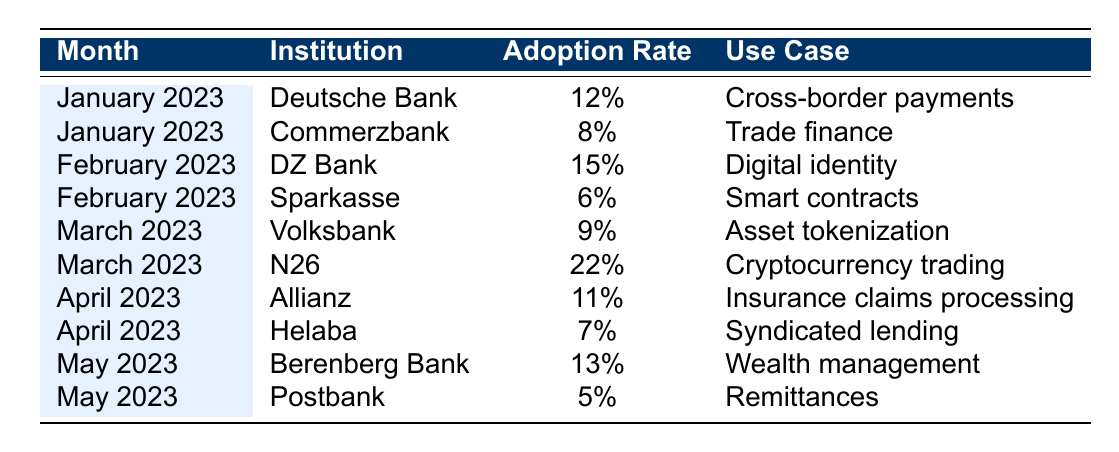What is the highest adoption rate recorded in the table? The highest adoption rate is 22%, which is associated with N26 in March 2023.
Answer: 22% Which institution has the lowest adoption rate and when? The lowest adoption rate is 5%, identified with Postbank in May 2023.
Answer: Postbank in May 2023 What was the average adoption rate across all institutions for January 2023? For January, the adoption rates are 12% (Deutsche Bank) and 8% (Commerzbank). The average is (12 + 8) / 2 = 10%.
Answer: 10% Which month saw the highest adoption rate among the institutions listed? In March 2023, N26 had an adoption rate of 22%, the highest among the months displayed.
Answer: March 2023 Was there any institution that recorded an adoption rate of 10% or higher in April 2023? Yes, Allianz in April 2023 had an adoption rate of 11%.
Answer: Yes Calculate the total adoption rate for all institutions in May 2023. In May 2023, Berenberg Bank had 13% and Postbank had 5%. The total is 13 + 5 = 18%.
Answer: 18% Which use case had the highest adoption rate, and which institution was it associated with? The highest adoption rate belongs to the use case "Cryptocurrency trading" at 22% with N26 in March 2023.
Answer: Cryptocurrency trading with N26 Is there a correlation between the month and adoption rate trends among the financial institutions? Observing the monthly data, adoption rates fluctuate, indicating different institutional priorities rather than a clear trend associated with time.
Answer: No clear trend What would be the average adoption rate for all institutions listed in February 2023? In February, the adoption rates are 15% (DZ Bank) and 6% (Sparkasse). The average is (15 + 6) / 2 = 10.5%.
Answer: 10.5% Can you name an institution that focuses on trade finance and its adoption rate? Commerzbank is focused on trade finance with an adoption rate of 8% in January 2023.
Answer: Commerzbank, 8% 